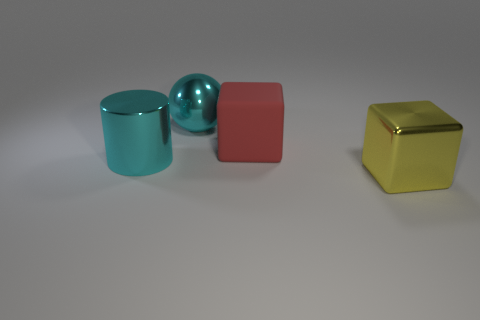Add 1 yellow cubes. How many objects exist? 5 Subtract all red blocks. How many blocks are left? 1 Subtract all red spheres. How many brown blocks are left? 0 Subtract 1 blocks. How many blocks are left? 1 Subtract all gray cubes. Subtract all gray spheres. How many cubes are left? 2 Subtract all large cyan shiny balls. Subtract all metallic objects. How many objects are left? 0 Add 4 large metal objects. How many large metal objects are left? 7 Add 2 tiny purple blocks. How many tiny purple blocks exist? 2 Subtract 0 cyan blocks. How many objects are left? 4 Subtract all balls. How many objects are left? 3 